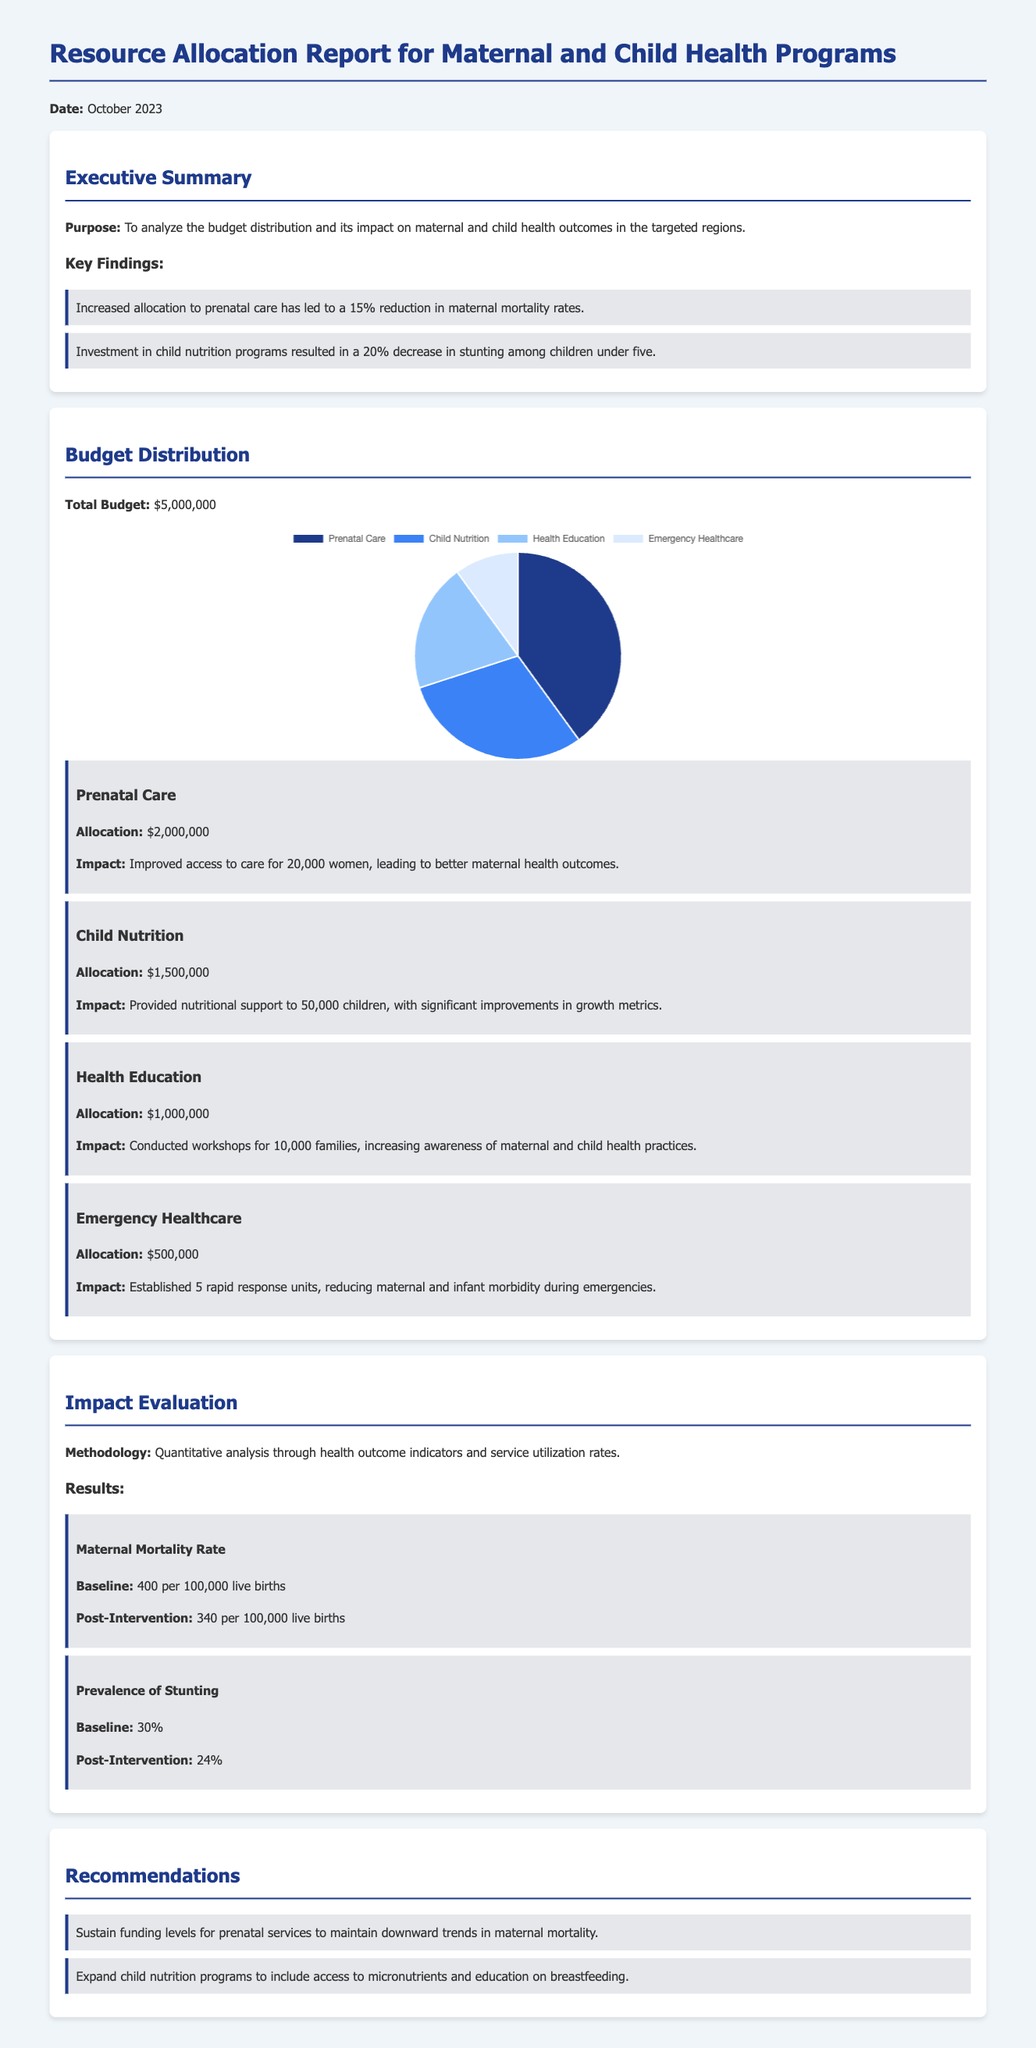What is the total budget? The total budget is explicitly stated in the document, which is $5,000,000.
Answer: $5,000,000 What is the allocation for prenatal care? The document specifies the allocation for prenatal care as $2,000,000.
Answer: $2,000,000 What percentage reduction was observed in maternal mortality rates? The report indicates a 15% reduction in maternal mortality rates as a key finding.
Answer: 15% How many women improved access to prenatal care? The impact of prenatal care is reported to improve access for 20,000 women.
Answer: 20,000 What is the post-intervention prevalence of stunting? The document states that the post-intervention prevalence of stunting is 24%.
Answer: 24% What was the baseline maternal mortality rate? The baseline maternal mortality rate is documented as 400 per 100,000 live births.
Answer: 400 per 100,000 live births How many rapid response units were established? The report mentions that 5 rapid response units were established for emergency healthcare.
Answer: 5 What recommendation is given for child nutrition programs? One recommendation is to expand child nutrition programs to include access to micronutrients and education on breastfeeding.
Answer: Access to micronutrients and education on breastfeeding 